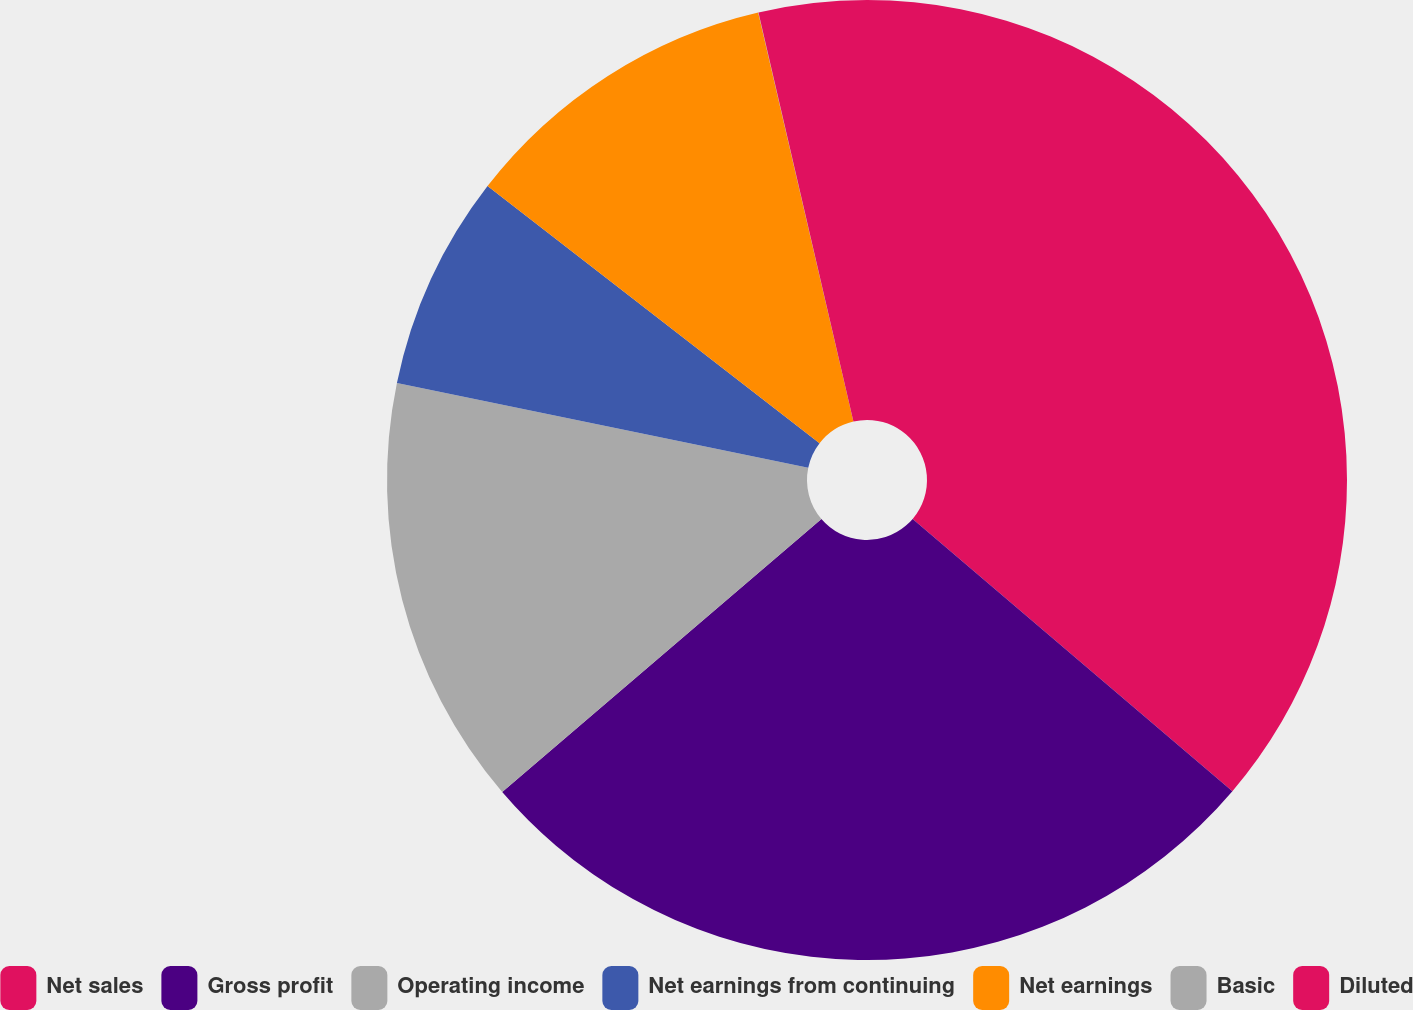Convert chart to OTSL. <chart><loc_0><loc_0><loc_500><loc_500><pie_chart><fcel>Net sales<fcel>Gross profit<fcel>Operating income<fcel>Net earnings from continuing<fcel>Net earnings<fcel>Basic<fcel>Diluted<nl><fcel>36.23%<fcel>27.51%<fcel>14.5%<fcel>7.25%<fcel>10.87%<fcel>0.01%<fcel>3.63%<nl></chart> 